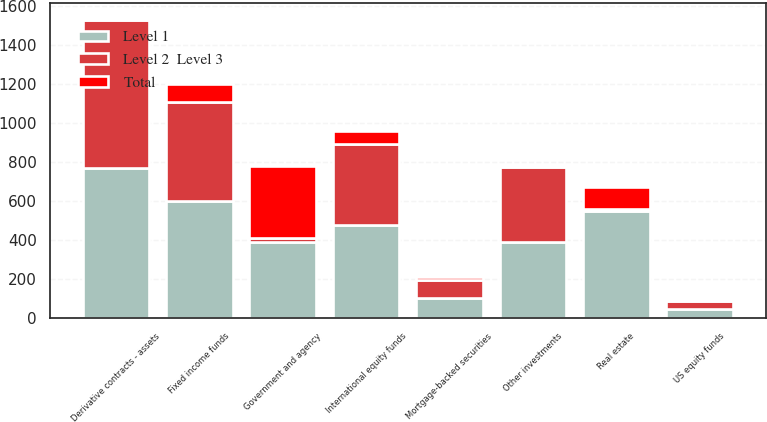<chart> <loc_0><loc_0><loc_500><loc_500><stacked_bar_chart><ecel><fcel>US equity funds<fcel>International equity funds<fcel>Government and agency<fcel>Mortgage-backed securities<fcel>Fixed income funds<fcel>Real estate<fcel>Other investments<fcel>Derivative contracts - assets<nl><fcel>Level 1<fcel>47<fcel>481<fcel>391<fcel>106<fcel>601<fcel>550<fcel>389<fcel>769<nl><fcel>Total<fcel>5<fcel>68<fcel>370<fcel>14<fcel>91<fcel>110<fcel>3<fcel>10<nl><fcel>Level 2  Level 3<fcel>42<fcel>413<fcel>21<fcel>92<fcel>510<fcel>12<fcel>386<fcel>759<nl></chart> 